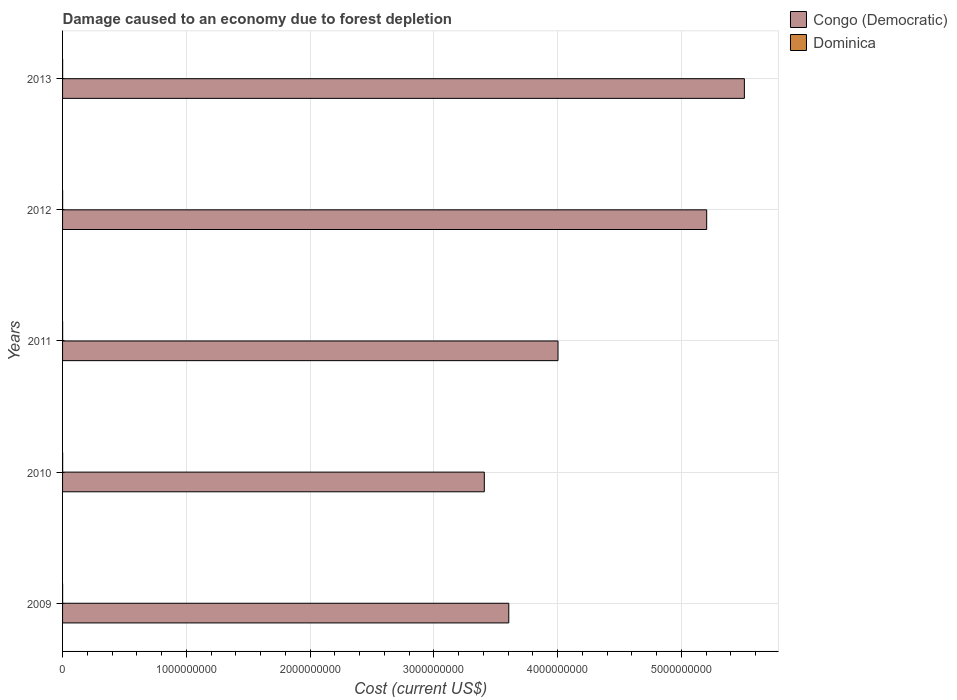Are the number of bars per tick equal to the number of legend labels?
Your answer should be very brief. Yes. Are the number of bars on each tick of the Y-axis equal?
Offer a very short reply. Yes. How many bars are there on the 2nd tick from the bottom?
Your answer should be very brief. 2. What is the cost of damage caused due to forest depletion in Congo (Democratic) in 2010?
Offer a terse response. 3.41e+09. Across all years, what is the maximum cost of damage caused due to forest depletion in Congo (Democratic)?
Your answer should be very brief. 5.51e+09. Across all years, what is the minimum cost of damage caused due to forest depletion in Dominica?
Provide a short and direct response. 3.04e+05. What is the total cost of damage caused due to forest depletion in Congo (Democratic) in the graph?
Ensure brevity in your answer.  2.17e+1. What is the difference between the cost of damage caused due to forest depletion in Congo (Democratic) in 2009 and that in 2010?
Offer a terse response. 1.98e+08. What is the difference between the cost of damage caused due to forest depletion in Congo (Democratic) in 2009 and the cost of damage caused due to forest depletion in Dominica in 2013?
Offer a terse response. 3.61e+09. What is the average cost of damage caused due to forest depletion in Dominica per year?
Make the answer very short. 4.88e+05. In the year 2013, what is the difference between the cost of damage caused due to forest depletion in Congo (Democratic) and cost of damage caused due to forest depletion in Dominica?
Provide a short and direct response. 5.51e+09. What is the ratio of the cost of damage caused due to forest depletion in Dominica in 2009 to that in 2013?
Your response must be concise. 0.6. Is the cost of damage caused due to forest depletion in Congo (Democratic) in 2009 less than that in 2013?
Your response must be concise. Yes. What is the difference between the highest and the second highest cost of damage caused due to forest depletion in Dominica?
Offer a terse response. 1.27e+05. What is the difference between the highest and the lowest cost of damage caused due to forest depletion in Dominica?
Ensure brevity in your answer.  3.33e+05. Is the sum of the cost of damage caused due to forest depletion in Congo (Democratic) in 2011 and 2013 greater than the maximum cost of damage caused due to forest depletion in Dominica across all years?
Provide a short and direct response. Yes. What does the 2nd bar from the top in 2011 represents?
Provide a succinct answer. Congo (Democratic). What does the 1st bar from the bottom in 2010 represents?
Provide a succinct answer. Congo (Democratic). How many bars are there?
Offer a terse response. 10. Are all the bars in the graph horizontal?
Offer a terse response. Yes. How many years are there in the graph?
Ensure brevity in your answer.  5. Are the values on the major ticks of X-axis written in scientific E-notation?
Provide a short and direct response. No. Where does the legend appear in the graph?
Keep it short and to the point. Top right. How many legend labels are there?
Keep it short and to the point. 2. What is the title of the graph?
Your answer should be very brief. Damage caused to an economy due to forest depletion. Does "Iraq" appear as one of the legend labels in the graph?
Give a very brief answer. No. What is the label or title of the X-axis?
Offer a terse response. Cost (current US$). What is the label or title of the Y-axis?
Give a very brief answer. Years. What is the Cost (current US$) of Congo (Democratic) in 2009?
Make the answer very short. 3.61e+09. What is the Cost (current US$) in Dominica in 2009?
Offer a terse response. 3.04e+05. What is the Cost (current US$) of Congo (Democratic) in 2010?
Your answer should be very brief. 3.41e+09. What is the Cost (current US$) of Dominica in 2010?
Keep it short and to the point. 6.37e+05. What is the Cost (current US$) in Congo (Democratic) in 2011?
Provide a succinct answer. 4.00e+09. What is the Cost (current US$) in Dominica in 2011?
Ensure brevity in your answer.  4.94e+05. What is the Cost (current US$) in Congo (Democratic) in 2012?
Ensure brevity in your answer.  5.21e+09. What is the Cost (current US$) of Dominica in 2012?
Provide a succinct answer. 4.94e+05. What is the Cost (current US$) of Congo (Democratic) in 2013?
Offer a very short reply. 5.51e+09. What is the Cost (current US$) of Dominica in 2013?
Ensure brevity in your answer.  5.10e+05. Across all years, what is the maximum Cost (current US$) in Congo (Democratic)?
Your response must be concise. 5.51e+09. Across all years, what is the maximum Cost (current US$) in Dominica?
Your answer should be very brief. 6.37e+05. Across all years, what is the minimum Cost (current US$) in Congo (Democratic)?
Your answer should be compact. 3.41e+09. Across all years, what is the minimum Cost (current US$) in Dominica?
Give a very brief answer. 3.04e+05. What is the total Cost (current US$) of Congo (Democratic) in the graph?
Give a very brief answer. 2.17e+1. What is the total Cost (current US$) of Dominica in the graph?
Give a very brief answer. 2.44e+06. What is the difference between the Cost (current US$) of Congo (Democratic) in 2009 and that in 2010?
Your response must be concise. 1.98e+08. What is the difference between the Cost (current US$) in Dominica in 2009 and that in 2010?
Your answer should be very brief. -3.33e+05. What is the difference between the Cost (current US$) of Congo (Democratic) in 2009 and that in 2011?
Keep it short and to the point. -3.98e+08. What is the difference between the Cost (current US$) in Dominica in 2009 and that in 2011?
Your response must be concise. -1.90e+05. What is the difference between the Cost (current US$) in Congo (Democratic) in 2009 and that in 2012?
Provide a succinct answer. -1.60e+09. What is the difference between the Cost (current US$) in Dominica in 2009 and that in 2012?
Your response must be concise. -1.90e+05. What is the difference between the Cost (current US$) in Congo (Democratic) in 2009 and that in 2013?
Ensure brevity in your answer.  -1.90e+09. What is the difference between the Cost (current US$) in Dominica in 2009 and that in 2013?
Your answer should be very brief. -2.06e+05. What is the difference between the Cost (current US$) of Congo (Democratic) in 2010 and that in 2011?
Offer a terse response. -5.96e+08. What is the difference between the Cost (current US$) in Dominica in 2010 and that in 2011?
Your response must be concise. 1.44e+05. What is the difference between the Cost (current US$) of Congo (Democratic) in 2010 and that in 2012?
Your response must be concise. -1.80e+09. What is the difference between the Cost (current US$) of Dominica in 2010 and that in 2012?
Offer a very short reply. 1.43e+05. What is the difference between the Cost (current US$) in Congo (Democratic) in 2010 and that in 2013?
Provide a succinct answer. -2.10e+09. What is the difference between the Cost (current US$) in Dominica in 2010 and that in 2013?
Ensure brevity in your answer.  1.27e+05. What is the difference between the Cost (current US$) of Congo (Democratic) in 2011 and that in 2012?
Offer a very short reply. -1.20e+09. What is the difference between the Cost (current US$) in Dominica in 2011 and that in 2012?
Keep it short and to the point. -519.05. What is the difference between the Cost (current US$) of Congo (Democratic) in 2011 and that in 2013?
Give a very brief answer. -1.51e+09. What is the difference between the Cost (current US$) in Dominica in 2011 and that in 2013?
Your response must be concise. -1.61e+04. What is the difference between the Cost (current US$) in Congo (Democratic) in 2012 and that in 2013?
Your answer should be very brief. -3.05e+08. What is the difference between the Cost (current US$) in Dominica in 2012 and that in 2013?
Provide a short and direct response. -1.56e+04. What is the difference between the Cost (current US$) in Congo (Democratic) in 2009 and the Cost (current US$) in Dominica in 2010?
Your answer should be compact. 3.61e+09. What is the difference between the Cost (current US$) in Congo (Democratic) in 2009 and the Cost (current US$) in Dominica in 2011?
Ensure brevity in your answer.  3.61e+09. What is the difference between the Cost (current US$) of Congo (Democratic) in 2009 and the Cost (current US$) of Dominica in 2012?
Offer a terse response. 3.61e+09. What is the difference between the Cost (current US$) of Congo (Democratic) in 2009 and the Cost (current US$) of Dominica in 2013?
Your response must be concise. 3.61e+09. What is the difference between the Cost (current US$) in Congo (Democratic) in 2010 and the Cost (current US$) in Dominica in 2011?
Offer a terse response. 3.41e+09. What is the difference between the Cost (current US$) in Congo (Democratic) in 2010 and the Cost (current US$) in Dominica in 2012?
Your answer should be very brief. 3.41e+09. What is the difference between the Cost (current US$) in Congo (Democratic) in 2010 and the Cost (current US$) in Dominica in 2013?
Keep it short and to the point. 3.41e+09. What is the difference between the Cost (current US$) in Congo (Democratic) in 2011 and the Cost (current US$) in Dominica in 2012?
Provide a succinct answer. 4.00e+09. What is the difference between the Cost (current US$) of Congo (Democratic) in 2011 and the Cost (current US$) of Dominica in 2013?
Make the answer very short. 4.00e+09. What is the difference between the Cost (current US$) in Congo (Democratic) in 2012 and the Cost (current US$) in Dominica in 2013?
Ensure brevity in your answer.  5.21e+09. What is the average Cost (current US$) of Congo (Democratic) per year?
Keep it short and to the point. 4.35e+09. What is the average Cost (current US$) of Dominica per year?
Make the answer very short. 4.88e+05. In the year 2009, what is the difference between the Cost (current US$) in Congo (Democratic) and Cost (current US$) in Dominica?
Provide a succinct answer. 3.61e+09. In the year 2010, what is the difference between the Cost (current US$) in Congo (Democratic) and Cost (current US$) in Dominica?
Your answer should be compact. 3.41e+09. In the year 2011, what is the difference between the Cost (current US$) of Congo (Democratic) and Cost (current US$) of Dominica?
Your response must be concise. 4.00e+09. In the year 2012, what is the difference between the Cost (current US$) of Congo (Democratic) and Cost (current US$) of Dominica?
Make the answer very short. 5.21e+09. In the year 2013, what is the difference between the Cost (current US$) in Congo (Democratic) and Cost (current US$) in Dominica?
Provide a short and direct response. 5.51e+09. What is the ratio of the Cost (current US$) of Congo (Democratic) in 2009 to that in 2010?
Offer a terse response. 1.06. What is the ratio of the Cost (current US$) in Dominica in 2009 to that in 2010?
Provide a succinct answer. 0.48. What is the ratio of the Cost (current US$) in Congo (Democratic) in 2009 to that in 2011?
Offer a terse response. 0.9. What is the ratio of the Cost (current US$) in Dominica in 2009 to that in 2011?
Your response must be concise. 0.62. What is the ratio of the Cost (current US$) of Congo (Democratic) in 2009 to that in 2012?
Your answer should be very brief. 0.69. What is the ratio of the Cost (current US$) of Dominica in 2009 to that in 2012?
Offer a very short reply. 0.61. What is the ratio of the Cost (current US$) in Congo (Democratic) in 2009 to that in 2013?
Your answer should be very brief. 0.65. What is the ratio of the Cost (current US$) in Dominica in 2009 to that in 2013?
Provide a short and direct response. 0.6. What is the ratio of the Cost (current US$) of Congo (Democratic) in 2010 to that in 2011?
Your response must be concise. 0.85. What is the ratio of the Cost (current US$) of Dominica in 2010 to that in 2011?
Make the answer very short. 1.29. What is the ratio of the Cost (current US$) in Congo (Democratic) in 2010 to that in 2012?
Your answer should be very brief. 0.65. What is the ratio of the Cost (current US$) in Dominica in 2010 to that in 2012?
Your response must be concise. 1.29. What is the ratio of the Cost (current US$) of Congo (Democratic) in 2010 to that in 2013?
Your response must be concise. 0.62. What is the ratio of the Cost (current US$) of Congo (Democratic) in 2011 to that in 2012?
Keep it short and to the point. 0.77. What is the ratio of the Cost (current US$) of Congo (Democratic) in 2011 to that in 2013?
Your answer should be very brief. 0.73. What is the ratio of the Cost (current US$) in Dominica in 2011 to that in 2013?
Provide a succinct answer. 0.97. What is the ratio of the Cost (current US$) in Congo (Democratic) in 2012 to that in 2013?
Keep it short and to the point. 0.94. What is the ratio of the Cost (current US$) of Dominica in 2012 to that in 2013?
Offer a terse response. 0.97. What is the difference between the highest and the second highest Cost (current US$) of Congo (Democratic)?
Keep it short and to the point. 3.05e+08. What is the difference between the highest and the second highest Cost (current US$) in Dominica?
Offer a very short reply. 1.27e+05. What is the difference between the highest and the lowest Cost (current US$) of Congo (Democratic)?
Provide a succinct answer. 2.10e+09. What is the difference between the highest and the lowest Cost (current US$) in Dominica?
Offer a terse response. 3.33e+05. 